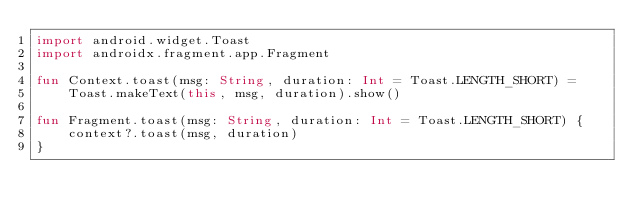Convert code to text. <code><loc_0><loc_0><loc_500><loc_500><_Kotlin_>import android.widget.Toast
import androidx.fragment.app.Fragment

fun Context.toast(msg: String, duration: Int = Toast.LENGTH_SHORT) =
    Toast.makeText(this, msg, duration).show()

fun Fragment.toast(msg: String, duration: Int = Toast.LENGTH_SHORT) {
    context?.toast(msg, duration)
}

</code> 